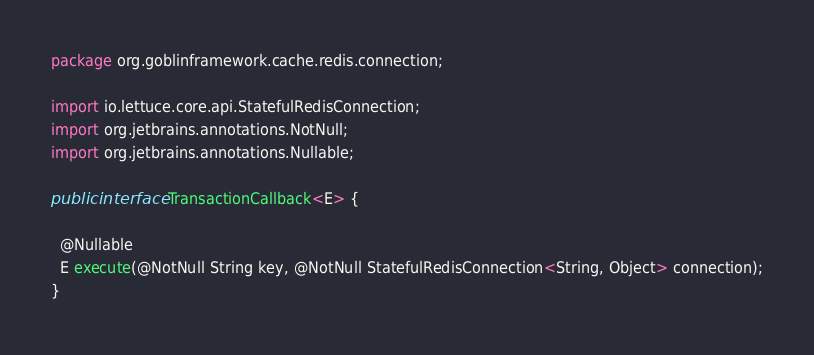Convert code to text. <code><loc_0><loc_0><loc_500><loc_500><_Java_>package org.goblinframework.cache.redis.connection;

import io.lettuce.core.api.StatefulRedisConnection;
import org.jetbrains.annotations.NotNull;
import org.jetbrains.annotations.Nullable;

public interface TransactionCallback<E> {

  @Nullable
  E execute(@NotNull String key, @NotNull StatefulRedisConnection<String, Object> connection);
}
</code> 